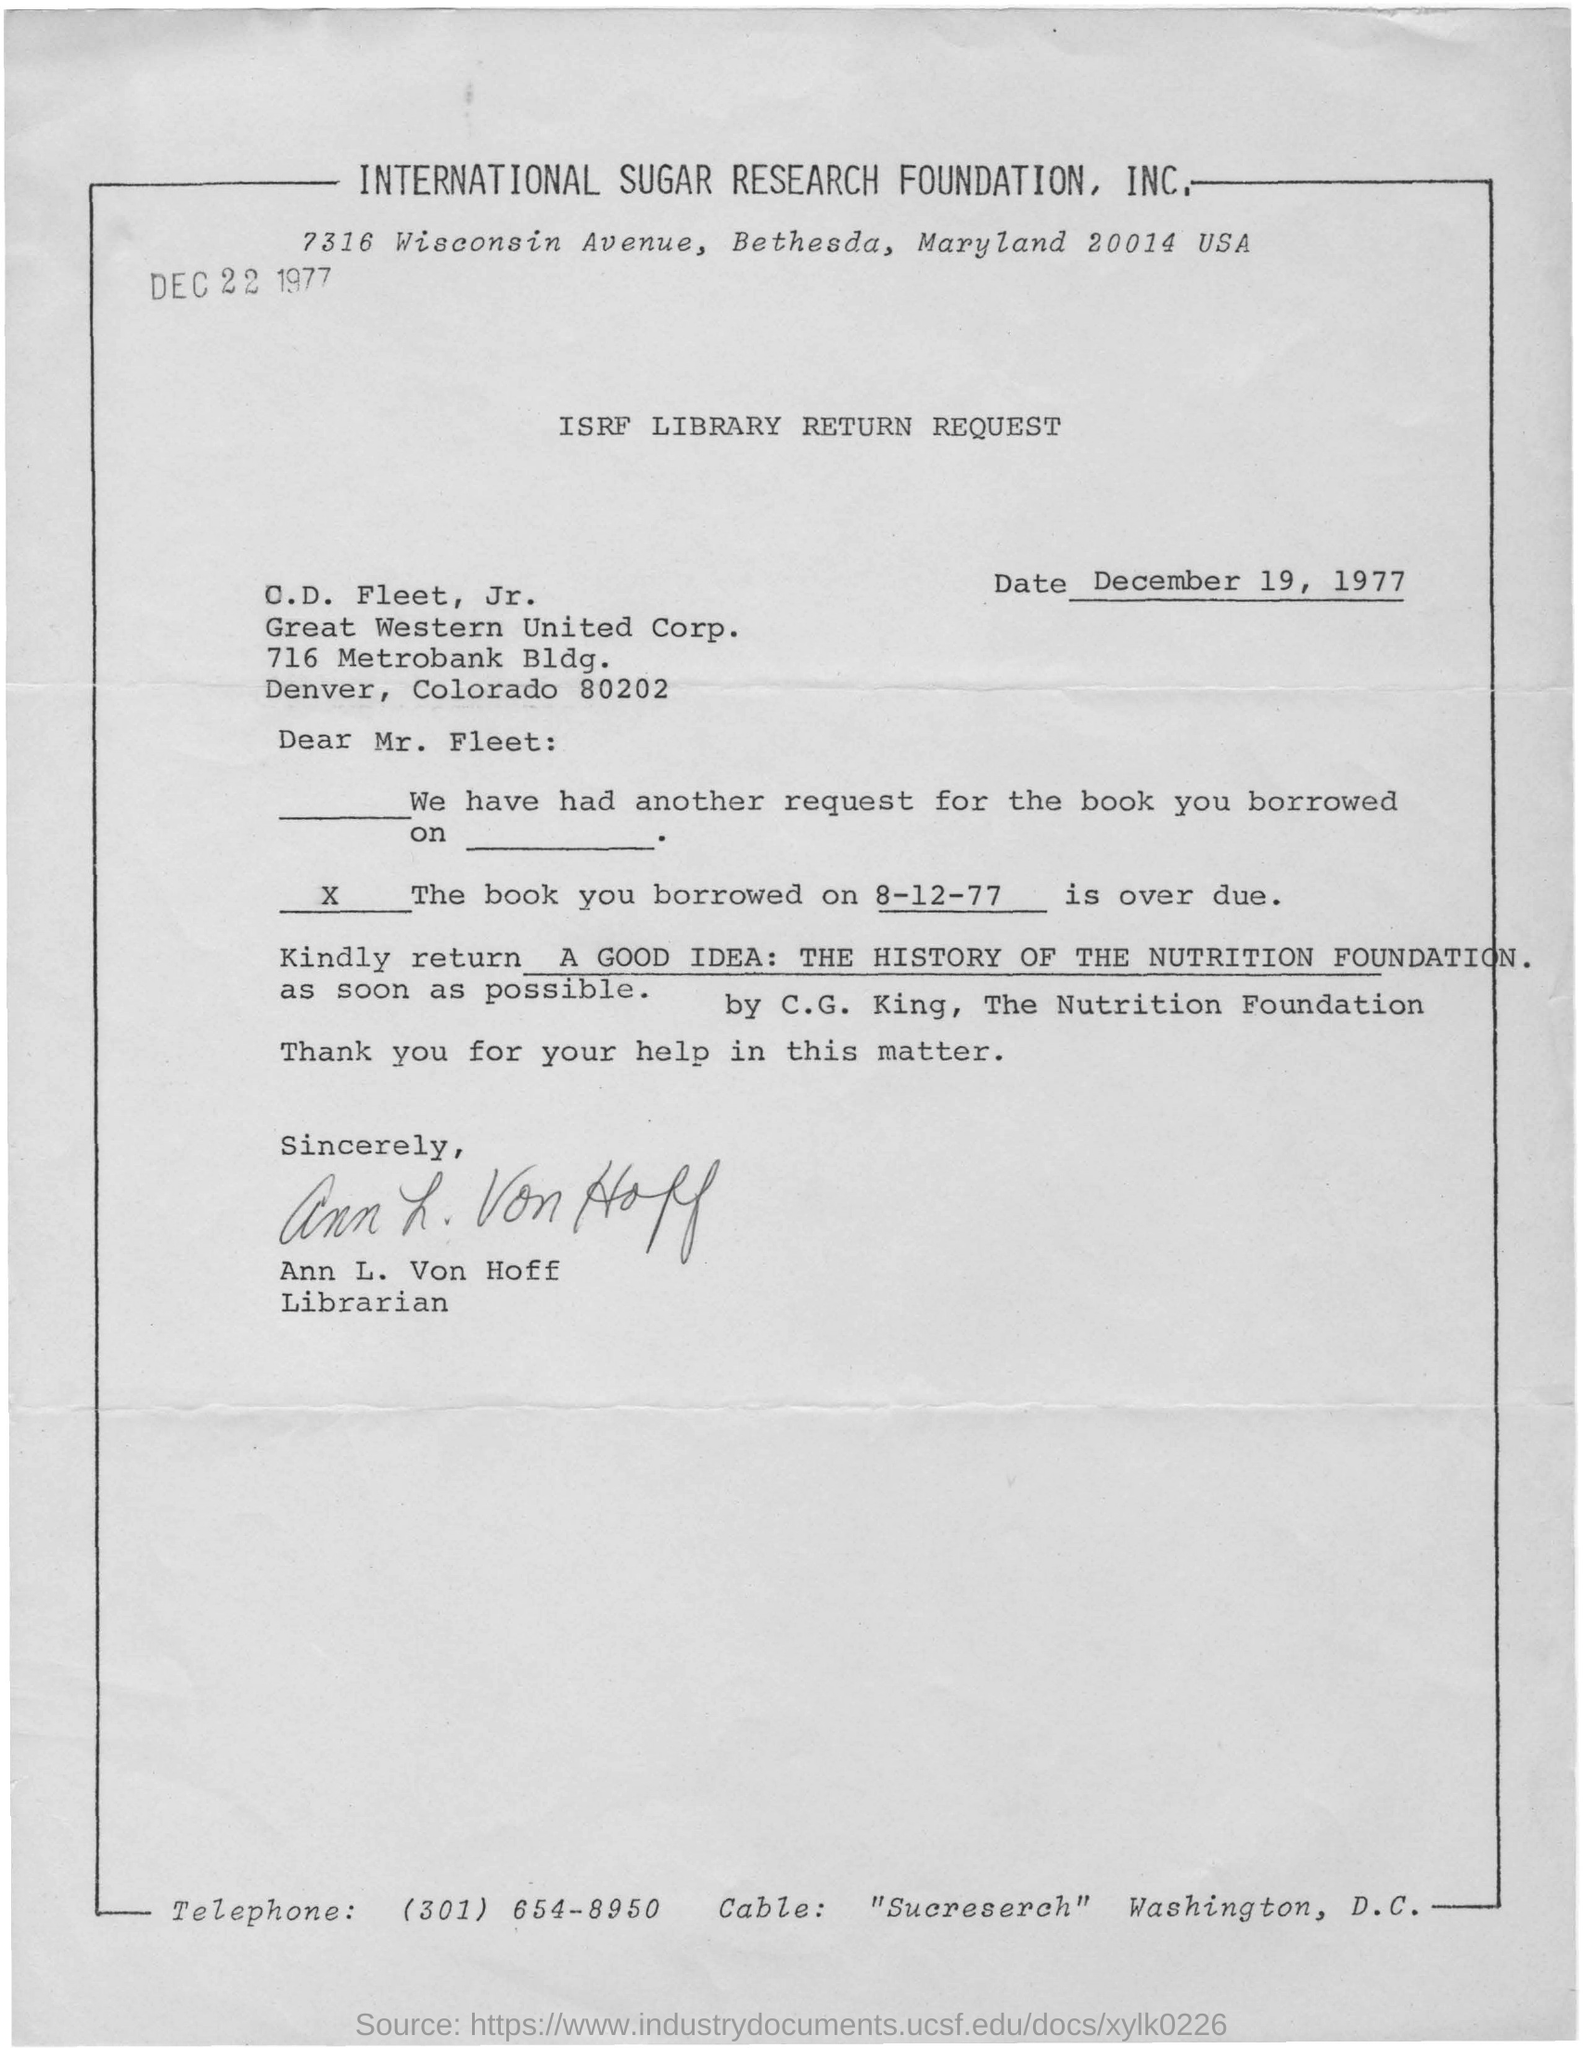Give some essential details in this illustration. It is Ann L. von Hoff who is writing a letter to C.D. Fleet. The letter was dated on December 19, 1977. The telephone number located at the bottom of the letter is (301) 654-8950. The International Sugar Research Foundation, Inc. is located at 7316 Wisconsin avenue in Bethesda, Maryland 20014, USA. 